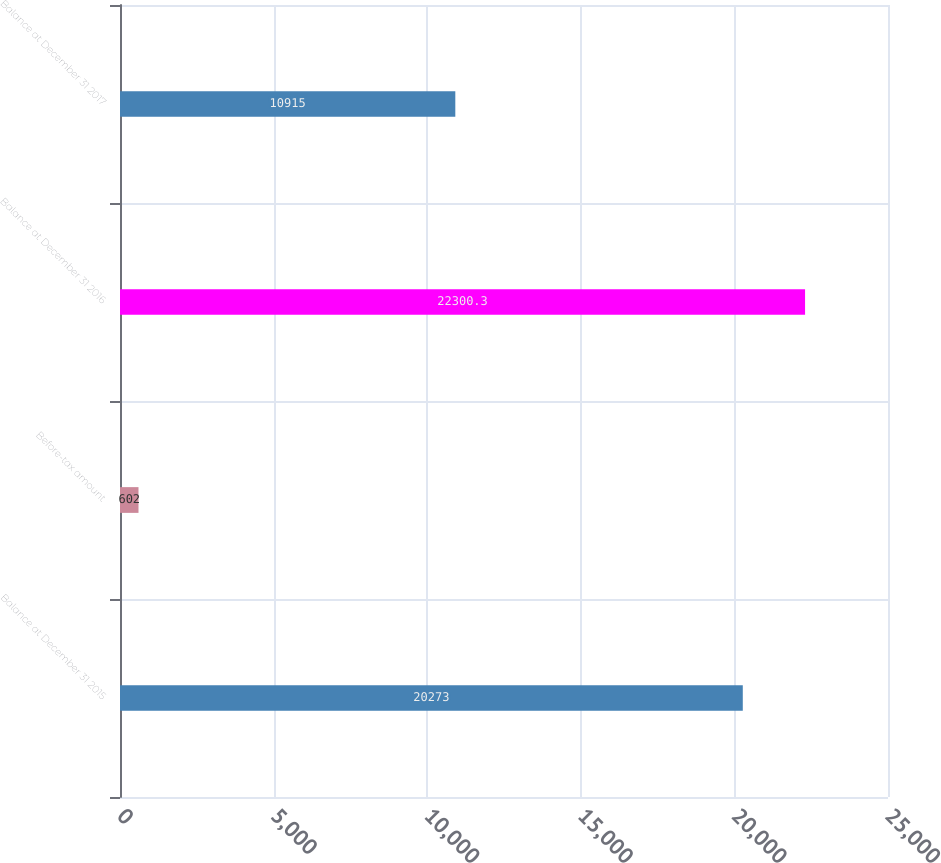Convert chart to OTSL. <chart><loc_0><loc_0><loc_500><loc_500><bar_chart><fcel>Balance at December 31 2015<fcel>Before-tax amount<fcel>Balance at December 31 2016<fcel>Balance at December 31 2017<nl><fcel>20273<fcel>602<fcel>22300.3<fcel>10915<nl></chart> 